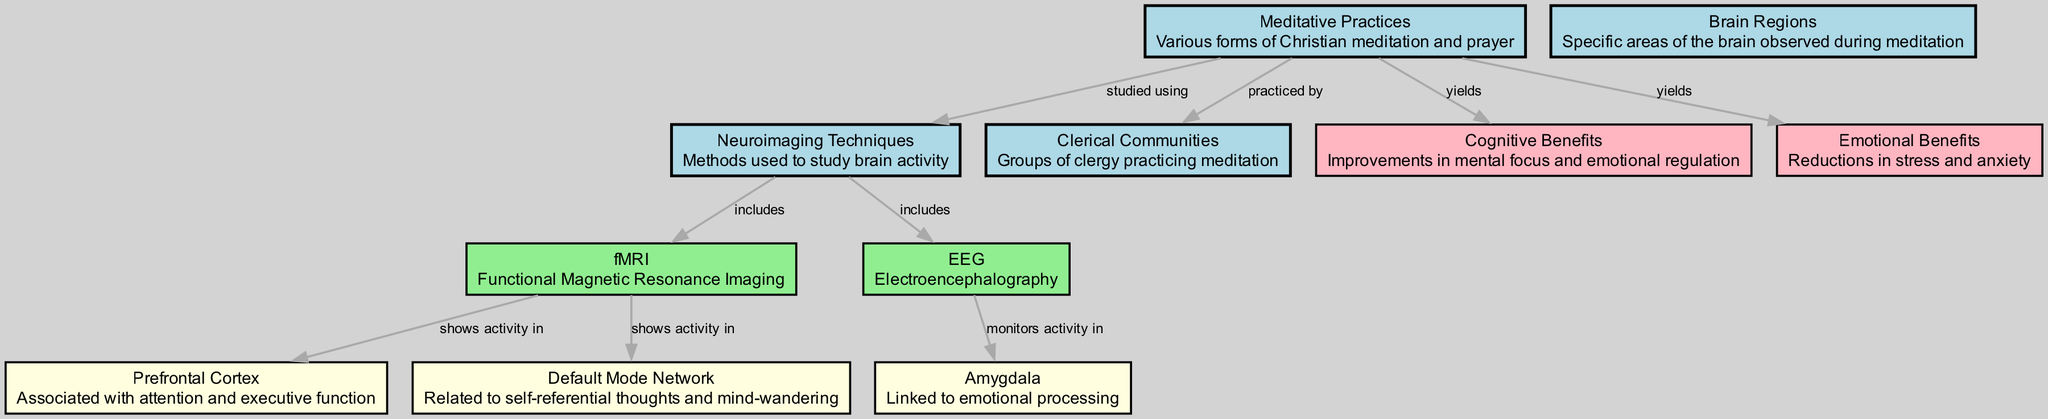What are the types of neuroimaging techniques mentioned in the diagram? The diagram includes two neuroimaging techniques: fMRI and EEG. They are specified as part of the nodes related to neuroimaging methods used in the studies.
Answer: fMRI, EEG Which brain region is monitored for activity by EEG? In the diagram, the arrow from EEG to the Amygdala indicates that EEG monitors activity in this particular brain region, which is associated with emotional processing.
Answer: Amygdala How many nodes describe meditative practices and their effects? Counting the nodes related to meditative practices and their outcomes, there are three: "Meditative Practices," "Cognitive Benefits," and "Emotional Benefits."
Answer: 3 What brain region shows activity related to self-referential thoughts? According to the diagram, the Default Mode Network is specifically noted to show activity associated with self-referential thoughts and mind-wandering.
Answer: Default Mode Network What benefits does meditation yield according to the diagram? The diagram indicates that meditation yields both cognitive and emotional benefits, showing improvements in mental focus and reductions in stress.
Answer: Cognitive Benefits, Emotional Benefits Which brain region is associated with attention and executive function? The diagram highlights the Prefrontal Cortex as being associated with attention and executive function based on the information provided in the nodes.
Answer: Prefrontal Cortex What is the relationship between meditative practices and clerical communities? The diagram shows a direct connection indicating that meditative practices are practiced by clerical communities, establishing a relationship between the two nodes.
Answer: practiced by Which neuroimaging technique is linked to functional studies of brain activity during meditation? The diagram highlights fMRI as the neuroimaging technique that includes studying functional brain activity during meditation.
Answer: fMRI In total, how many edges are present in the diagram? By counting the connections (or edges) shown in the diagram, there are a total of eight edges connecting various nodes together in the representation of relationships and interactions.
Answer: 8 